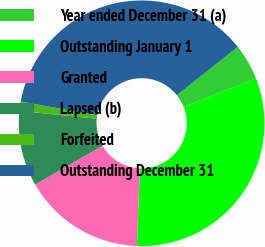<chart> <loc_0><loc_0><loc_500><loc_500><pie_chart><fcel>Year ended December 31 (a)<fcel>Outstanding January 1<fcel>Granted<fcel>Lapsed (b)<fcel>Forfeited<fcel>Outstanding December 31<nl><fcel>4.75%<fcel>31.55%<fcel>16.07%<fcel>9.92%<fcel>1.22%<fcel>36.48%<nl></chart> 